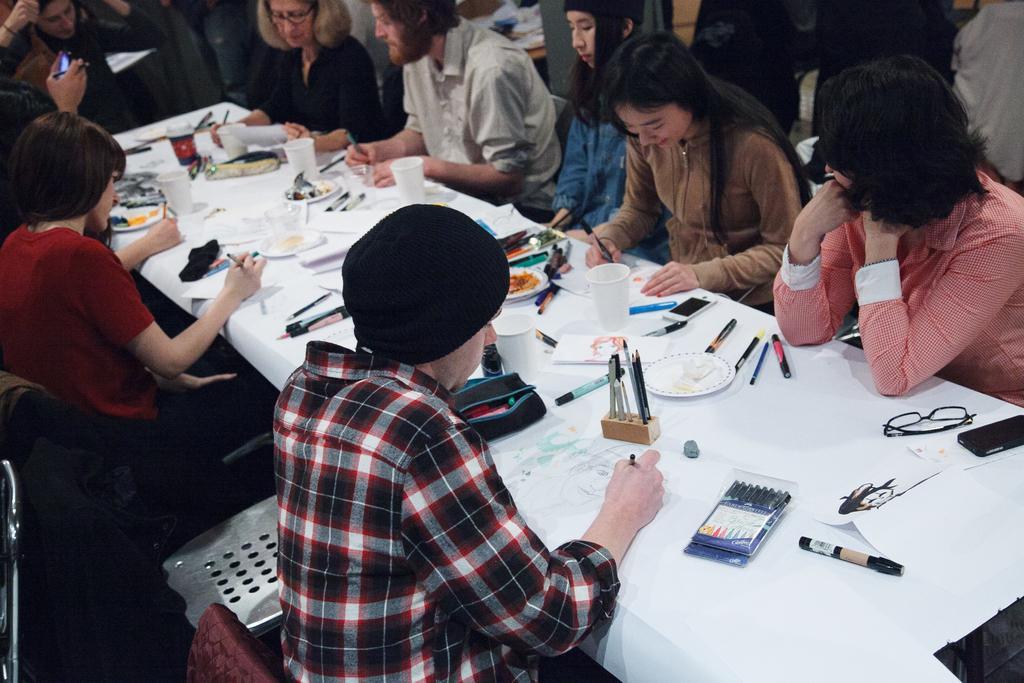Can you describe this image briefly? In this image I see number of people sitting on the chairs and there is a table in front of them and there are lot of things on it. 